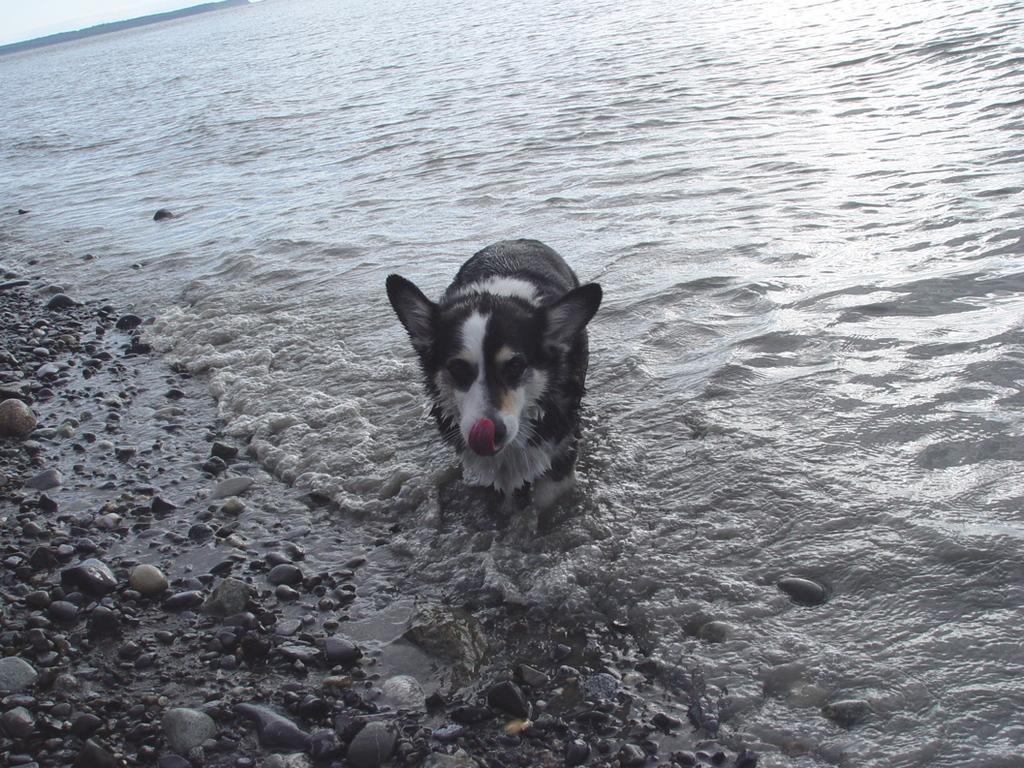Could you give a brief overview of what you see in this image? In this image I can see a dog standing in the water. There are stones on the left. 